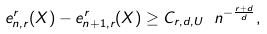<formula> <loc_0><loc_0><loc_500><loc_500>e ^ { r } _ { n , r } ( X ) - e ^ { r } _ { n + 1 , r } ( X ) \geq C _ { r , d , U } \ n ^ { - \frac { r + d } { d } } ,</formula> 